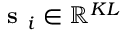<formula> <loc_0><loc_0><loc_500><loc_500>s _ { i } \in \mathbb { R } ^ { K L }</formula> 